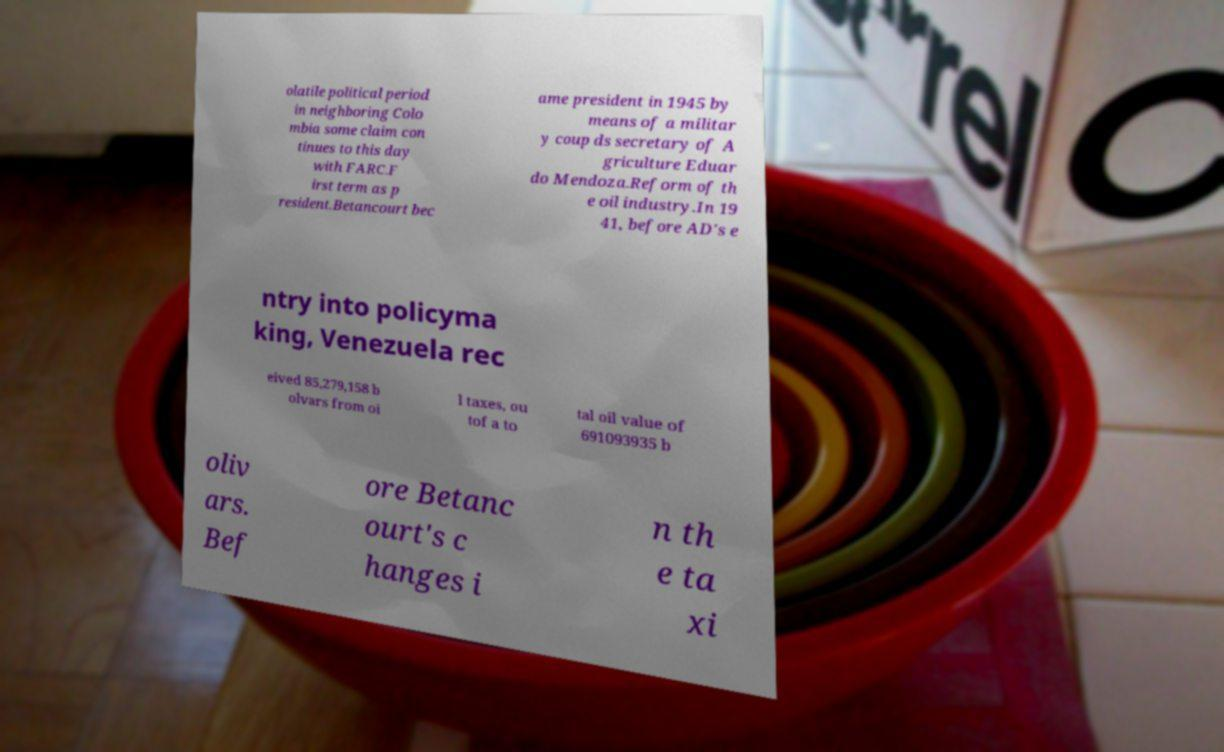I need the written content from this picture converted into text. Can you do that? olatile political period in neighboring Colo mbia some claim con tinues to this day with FARC.F irst term as p resident.Betancourt bec ame president in 1945 by means of a militar y coup ds secretary of A griculture Eduar do Mendoza.Reform of th e oil industry.In 19 41, before AD's e ntry into policyma king, Venezuela rec eived 85,279,158 b olvars from oi l taxes, ou tof a to tal oil value of 691093935 b oliv ars. Bef ore Betanc ourt's c hanges i n th e ta xi 